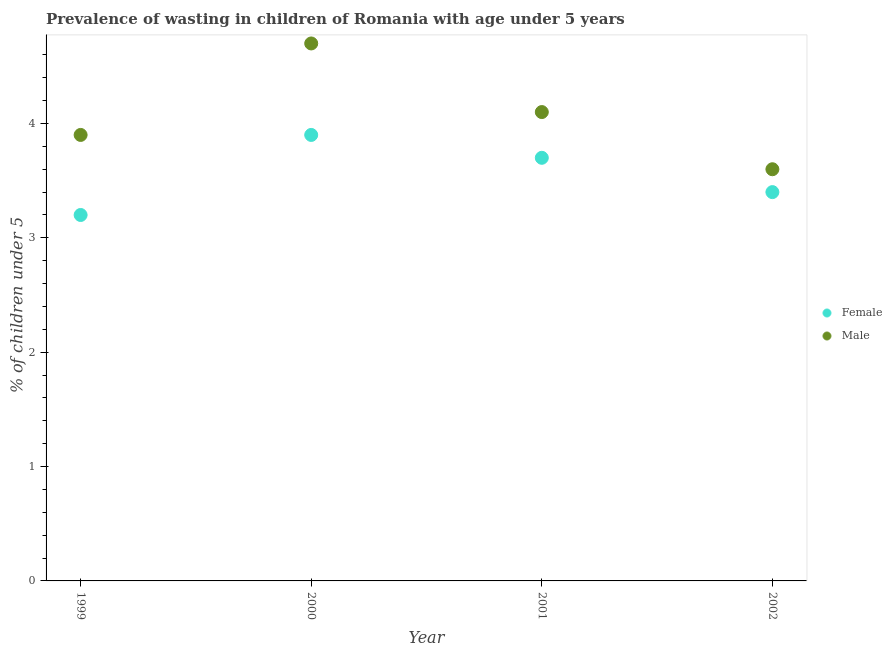How many different coloured dotlines are there?
Offer a very short reply. 2. Is the number of dotlines equal to the number of legend labels?
Your answer should be compact. Yes. What is the percentage of undernourished female children in 2002?
Provide a short and direct response. 3.4. Across all years, what is the maximum percentage of undernourished female children?
Give a very brief answer. 3.9. Across all years, what is the minimum percentage of undernourished male children?
Your answer should be compact. 3.6. What is the total percentage of undernourished female children in the graph?
Provide a short and direct response. 14.2. What is the difference between the percentage of undernourished male children in 2001 and that in 2002?
Make the answer very short. 0.5. What is the difference between the percentage of undernourished female children in 2002 and the percentage of undernourished male children in 2000?
Your answer should be compact. -1.3. What is the average percentage of undernourished male children per year?
Offer a very short reply. 4.07. In the year 2001, what is the difference between the percentage of undernourished male children and percentage of undernourished female children?
Give a very brief answer. 0.4. In how many years, is the percentage of undernourished female children greater than 4 %?
Make the answer very short. 0. What is the ratio of the percentage of undernourished male children in 1999 to that in 2000?
Provide a short and direct response. 0.83. Is the percentage of undernourished female children in 1999 less than that in 2001?
Ensure brevity in your answer.  Yes. Is the difference between the percentage of undernourished female children in 1999 and 2002 greater than the difference between the percentage of undernourished male children in 1999 and 2002?
Your response must be concise. No. What is the difference between the highest and the second highest percentage of undernourished male children?
Provide a short and direct response. 0.6. What is the difference between the highest and the lowest percentage of undernourished female children?
Your answer should be very brief. 0.7. Is the percentage of undernourished male children strictly greater than the percentage of undernourished female children over the years?
Ensure brevity in your answer.  Yes. How many dotlines are there?
Make the answer very short. 2. How many years are there in the graph?
Your response must be concise. 4. What is the difference between two consecutive major ticks on the Y-axis?
Offer a terse response. 1. Does the graph contain any zero values?
Provide a succinct answer. No. What is the title of the graph?
Make the answer very short. Prevalence of wasting in children of Romania with age under 5 years. What is the label or title of the Y-axis?
Your answer should be compact.  % of children under 5. What is the  % of children under 5 of Female in 1999?
Provide a short and direct response. 3.2. What is the  % of children under 5 of Male in 1999?
Make the answer very short. 3.9. What is the  % of children under 5 of Female in 2000?
Your response must be concise. 3.9. What is the  % of children under 5 in Male in 2000?
Give a very brief answer. 4.7. What is the  % of children under 5 in Female in 2001?
Your answer should be compact. 3.7. What is the  % of children under 5 of Male in 2001?
Your response must be concise. 4.1. What is the  % of children under 5 of Female in 2002?
Your answer should be compact. 3.4. What is the  % of children under 5 of Male in 2002?
Your response must be concise. 3.6. Across all years, what is the maximum  % of children under 5 of Female?
Make the answer very short. 3.9. Across all years, what is the maximum  % of children under 5 of Male?
Your answer should be very brief. 4.7. Across all years, what is the minimum  % of children under 5 of Female?
Keep it short and to the point. 3.2. Across all years, what is the minimum  % of children under 5 in Male?
Ensure brevity in your answer.  3.6. What is the total  % of children under 5 in Male in the graph?
Your answer should be compact. 16.3. What is the difference between the  % of children under 5 of Female in 1999 and that in 2000?
Your answer should be compact. -0.7. What is the difference between the  % of children under 5 of Male in 1999 and that in 2000?
Keep it short and to the point. -0.8. What is the difference between the  % of children under 5 in Female in 2000 and that in 2001?
Provide a short and direct response. 0.2. What is the difference between the  % of children under 5 in Male in 2000 and that in 2001?
Give a very brief answer. 0.6. What is the difference between the  % of children under 5 of Female in 2000 and that in 2002?
Make the answer very short. 0.5. What is the difference between the  % of children under 5 in Female in 1999 and the  % of children under 5 in Male in 2000?
Your answer should be compact. -1.5. What is the difference between the  % of children under 5 in Female in 1999 and the  % of children under 5 in Male in 2001?
Give a very brief answer. -0.9. What is the difference between the  % of children under 5 in Female in 1999 and the  % of children under 5 in Male in 2002?
Provide a short and direct response. -0.4. What is the difference between the  % of children under 5 in Female in 2000 and the  % of children under 5 in Male in 2001?
Provide a succinct answer. -0.2. What is the difference between the  % of children under 5 of Female in 2000 and the  % of children under 5 of Male in 2002?
Make the answer very short. 0.3. What is the difference between the  % of children under 5 in Female in 2001 and the  % of children under 5 in Male in 2002?
Give a very brief answer. 0.1. What is the average  % of children under 5 of Female per year?
Your response must be concise. 3.55. What is the average  % of children under 5 in Male per year?
Offer a terse response. 4.08. In the year 2001, what is the difference between the  % of children under 5 in Female and  % of children under 5 in Male?
Your answer should be compact. -0.4. In the year 2002, what is the difference between the  % of children under 5 of Female and  % of children under 5 of Male?
Provide a short and direct response. -0.2. What is the ratio of the  % of children under 5 in Female in 1999 to that in 2000?
Ensure brevity in your answer.  0.82. What is the ratio of the  % of children under 5 in Male in 1999 to that in 2000?
Give a very brief answer. 0.83. What is the ratio of the  % of children under 5 in Female in 1999 to that in 2001?
Offer a very short reply. 0.86. What is the ratio of the  % of children under 5 of Male in 1999 to that in 2001?
Offer a very short reply. 0.95. What is the ratio of the  % of children under 5 of Male in 1999 to that in 2002?
Ensure brevity in your answer.  1.08. What is the ratio of the  % of children under 5 of Female in 2000 to that in 2001?
Make the answer very short. 1.05. What is the ratio of the  % of children under 5 in Male in 2000 to that in 2001?
Ensure brevity in your answer.  1.15. What is the ratio of the  % of children under 5 of Female in 2000 to that in 2002?
Your response must be concise. 1.15. What is the ratio of the  % of children under 5 in Male in 2000 to that in 2002?
Your response must be concise. 1.31. What is the ratio of the  % of children under 5 of Female in 2001 to that in 2002?
Provide a short and direct response. 1.09. What is the ratio of the  % of children under 5 in Male in 2001 to that in 2002?
Give a very brief answer. 1.14. What is the difference between the highest and the second highest  % of children under 5 of Male?
Ensure brevity in your answer.  0.6. What is the difference between the highest and the lowest  % of children under 5 in Male?
Provide a short and direct response. 1.1. 